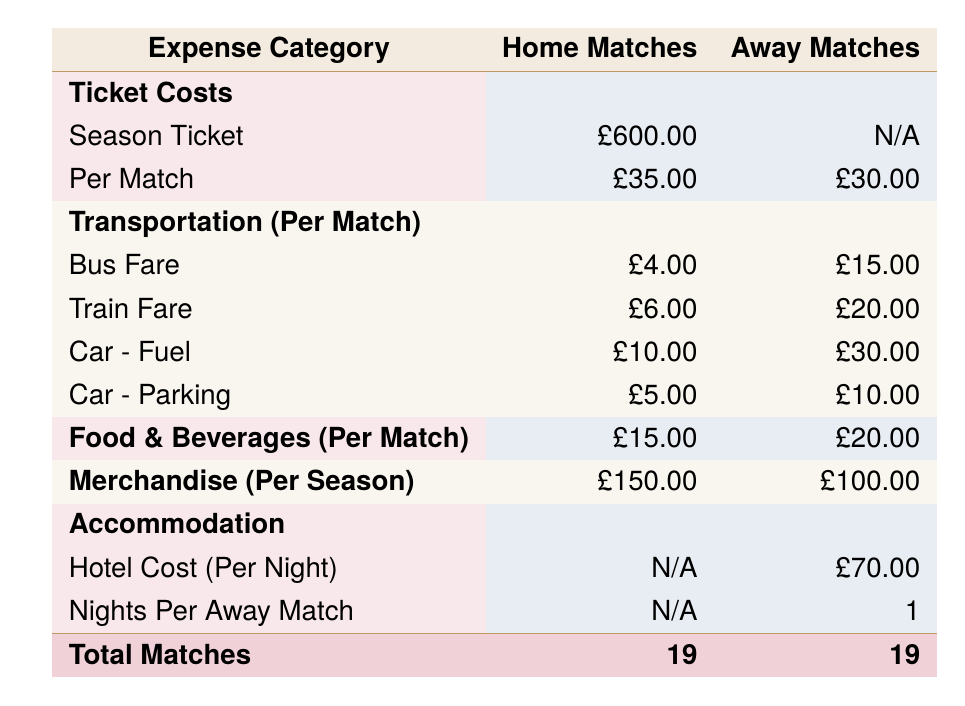What is the total cost of a season ticket for home matches? The table states that the season ticket cost for home matches is £600.
Answer: £600 How much do I spend on food and beverages for home matches in total? For home matches, food and beverages cost £15 per match, and there are 19 home matches. The total cost is 15 x 19 = £285.
Answer: £285 Is the ticket cost per match higher for home matches compared to away matches? The ticket cost for home matches is £35, while for away matches it is £30. Since £35 is greater than £30, the statement is true.
Answer: Yes What is the combined transportation cost per away match if I use the bus? For away matches, the bus fare is £15 per match. Thus, the transportation cost per away match using the bus alone is £15.
Answer: £15 When considering a season of both home and away matches, what is the total expenditure on merchandise? The merchandise cost for home matches is £150, and for away matches, it is £100. The total spending on merchandise for the season is 150 + 100 = £250.
Answer: £250 What is the total transportation cost per match for home matches when using car travel, including fuel and parking? For home matches, car fuel costs £10 and parking costs £5. Therefore, the total transportation cost per match using car travel is 10 + 5 = £15.
Answer: £15 How much more do I spend on accommodation for each away match compared to food and beverages? The accommodation cost is £70 for a hotel stay per away match, while the food and beverages cost is £20. Thus, the difference is 70 - 20 = £50.
Answer: £50 If I attend all home and away matches this season, what will my total cost be for tickets alone? For tickets, home matches cost £35 each and there are 19 matches, totaling 35 x 19 = £665. For away matches, each ticket costs £30, also for 19 matches, totaling 30 x 19 = £570. Combining both gives 665 + 570 = £1235.
Answer: £1235 What percentage of my total costs for home matches comes from the ticket prices if I don't have a season ticket? The total ticket cost for home matches is 35 x 19 = £665. The total cost for home matches (including all expenses) is 600 + 285 + 15 + 15 + 15 = £930. The percentage is (665 / 930) * 100 ≈ 71.3%.
Answer: Approximately 71.3% 